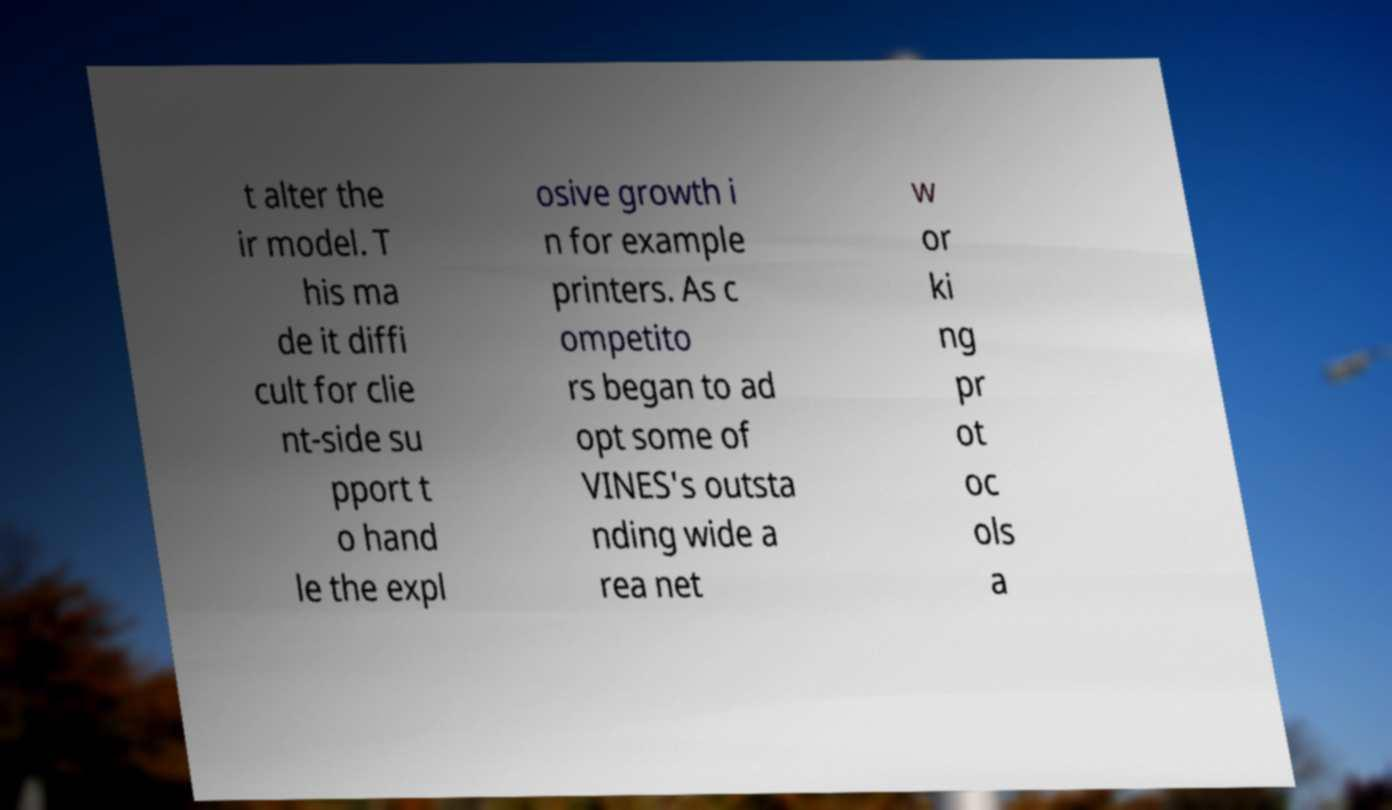Please identify and transcribe the text found in this image. t alter the ir model. T his ma de it diffi cult for clie nt-side su pport t o hand le the expl osive growth i n for example printers. As c ompetito rs began to ad opt some of VINES's outsta nding wide a rea net w or ki ng pr ot oc ols a 